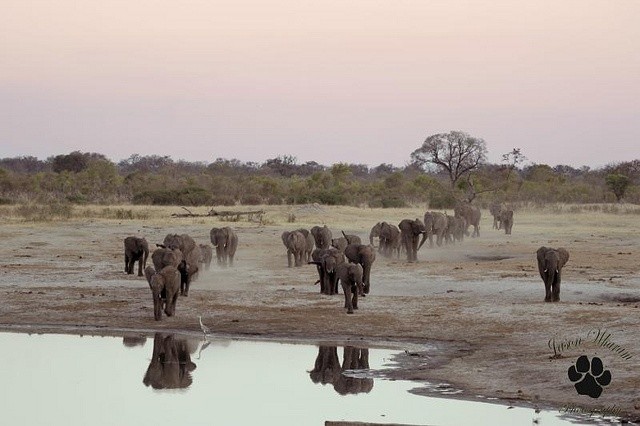Describe the objects in this image and their specific colors. I can see elephant in lightgray, gray, black, and darkgray tones, elephant in lightgray, black, gray, and maroon tones, elephant in lightgray, black, gray, and maroon tones, elephant in lightgray, black, and gray tones, and elephant in lightgray, gray, and black tones in this image. 